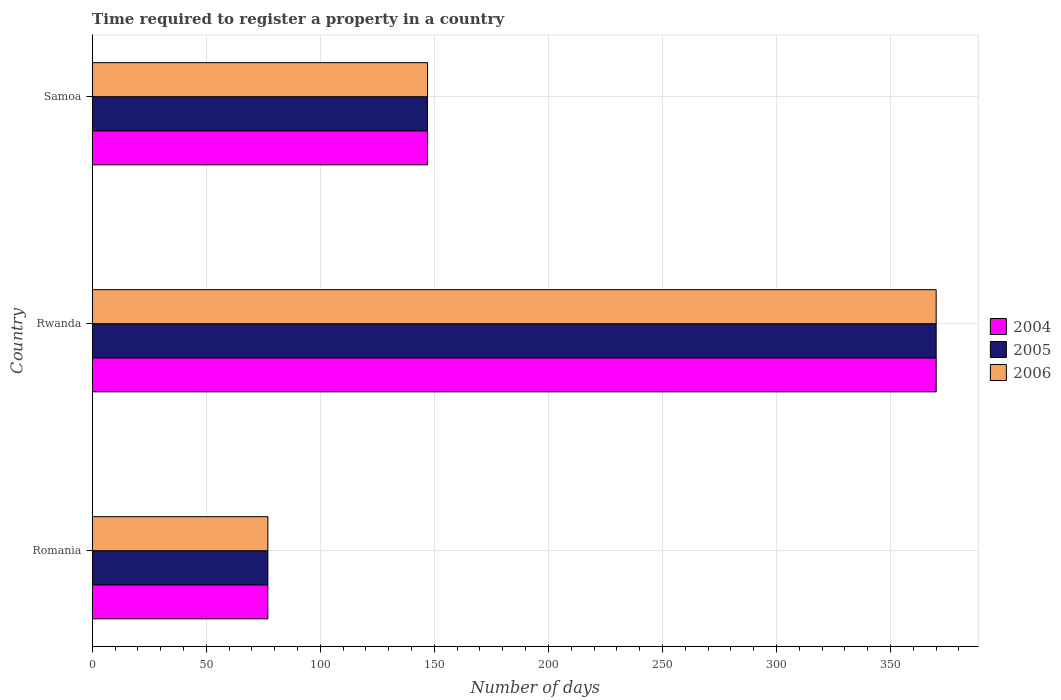Are the number of bars per tick equal to the number of legend labels?
Ensure brevity in your answer.  Yes. Are the number of bars on each tick of the Y-axis equal?
Offer a very short reply. Yes. How many bars are there on the 2nd tick from the top?
Provide a succinct answer. 3. What is the label of the 2nd group of bars from the top?
Ensure brevity in your answer.  Rwanda. What is the number of days required to register a property in 2006 in Rwanda?
Offer a very short reply. 370. Across all countries, what is the maximum number of days required to register a property in 2005?
Provide a succinct answer. 370. Across all countries, what is the minimum number of days required to register a property in 2006?
Provide a succinct answer. 77. In which country was the number of days required to register a property in 2004 maximum?
Offer a very short reply. Rwanda. In which country was the number of days required to register a property in 2005 minimum?
Offer a very short reply. Romania. What is the total number of days required to register a property in 2006 in the graph?
Offer a terse response. 594. What is the difference between the number of days required to register a property in 2005 in Romania and that in Rwanda?
Provide a succinct answer. -293. What is the difference between the number of days required to register a property in 2006 in Rwanda and the number of days required to register a property in 2004 in Samoa?
Provide a succinct answer. 223. What is the average number of days required to register a property in 2004 per country?
Your response must be concise. 198. What is the difference between the number of days required to register a property in 2005 and number of days required to register a property in 2006 in Rwanda?
Offer a very short reply. 0. What is the ratio of the number of days required to register a property in 2005 in Romania to that in Rwanda?
Provide a succinct answer. 0.21. Is the number of days required to register a property in 2004 in Romania less than that in Rwanda?
Provide a succinct answer. Yes. What is the difference between the highest and the second highest number of days required to register a property in 2004?
Your response must be concise. 223. What is the difference between the highest and the lowest number of days required to register a property in 2004?
Provide a short and direct response. 293. What does the 1st bar from the top in Samoa represents?
Your answer should be very brief. 2006. What does the 1st bar from the bottom in Rwanda represents?
Your answer should be compact. 2004. Is it the case that in every country, the sum of the number of days required to register a property in 2004 and number of days required to register a property in 2006 is greater than the number of days required to register a property in 2005?
Keep it short and to the point. Yes. How many bars are there?
Keep it short and to the point. 9. What is the difference between two consecutive major ticks on the X-axis?
Your response must be concise. 50. Does the graph contain any zero values?
Offer a terse response. No. Does the graph contain grids?
Keep it short and to the point. Yes. Where does the legend appear in the graph?
Provide a short and direct response. Center right. How many legend labels are there?
Offer a terse response. 3. How are the legend labels stacked?
Make the answer very short. Vertical. What is the title of the graph?
Keep it short and to the point. Time required to register a property in a country. What is the label or title of the X-axis?
Keep it short and to the point. Number of days. What is the Number of days in 2004 in Rwanda?
Your answer should be compact. 370. What is the Number of days of 2005 in Rwanda?
Offer a very short reply. 370. What is the Number of days of 2006 in Rwanda?
Your answer should be very brief. 370. What is the Number of days of 2004 in Samoa?
Your answer should be very brief. 147. What is the Number of days of 2005 in Samoa?
Provide a short and direct response. 147. What is the Number of days of 2006 in Samoa?
Make the answer very short. 147. Across all countries, what is the maximum Number of days in 2004?
Provide a succinct answer. 370. Across all countries, what is the maximum Number of days in 2005?
Your response must be concise. 370. Across all countries, what is the maximum Number of days of 2006?
Provide a short and direct response. 370. Across all countries, what is the minimum Number of days in 2004?
Provide a short and direct response. 77. Across all countries, what is the minimum Number of days of 2005?
Offer a very short reply. 77. Across all countries, what is the minimum Number of days of 2006?
Keep it short and to the point. 77. What is the total Number of days in 2004 in the graph?
Provide a short and direct response. 594. What is the total Number of days in 2005 in the graph?
Offer a terse response. 594. What is the total Number of days in 2006 in the graph?
Your response must be concise. 594. What is the difference between the Number of days in 2004 in Romania and that in Rwanda?
Make the answer very short. -293. What is the difference between the Number of days of 2005 in Romania and that in Rwanda?
Offer a very short reply. -293. What is the difference between the Number of days of 2006 in Romania and that in Rwanda?
Your answer should be very brief. -293. What is the difference between the Number of days of 2004 in Romania and that in Samoa?
Provide a succinct answer. -70. What is the difference between the Number of days of 2005 in Romania and that in Samoa?
Provide a short and direct response. -70. What is the difference between the Number of days of 2006 in Romania and that in Samoa?
Your response must be concise. -70. What is the difference between the Number of days in 2004 in Rwanda and that in Samoa?
Offer a very short reply. 223. What is the difference between the Number of days in 2005 in Rwanda and that in Samoa?
Ensure brevity in your answer.  223. What is the difference between the Number of days in 2006 in Rwanda and that in Samoa?
Provide a short and direct response. 223. What is the difference between the Number of days in 2004 in Romania and the Number of days in 2005 in Rwanda?
Provide a succinct answer. -293. What is the difference between the Number of days of 2004 in Romania and the Number of days of 2006 in Rwanda?
Provide a short and direct response. -293. What is the difference between the Number of days of 2005 in Romania and the Number of days of 2006 in Rwanda?
Keep it short and to the point. -293. What is the difference between the Number of days of 2004 in Romania and the Number of days of 2005 in Samoa?
Keep it short and to the point. -70. What is the difference between the Number of days in 2004 in Romania and the Number of days in 2006 in Samoa?
Offer a very short reply. -70. What is the difference between the Number of days in 2005 in Romania and the Number of days in 2006 in Samoa?
Keep it short and to the point. -70. What is the difference between the Number of days of 2004 in Rwanda and the Number of days of 2005 in Samoa?
Provide a succinct answer. 223. What is the difference between the Number of days of 2004 in Rwanda and the Number of days of 2006 in Samoa?
Ensure brevity in your answer.  223. What is the difference between the Number of days in 2005 in Rwanda and the Number of days in 2006 in Samoa?
Offer a very short reply. 223. What is the average Number of days in 2004 per country?
Your response must be concise. 198. What is the average Number of days of 2005 per country?
Make the answer very short. 198. What is the average Number of days in 2006 per country?
Make the answer very short. 198. What is the difference between the Number of days in 2005 and Number of days in 2006 in Romania?
Provide a short and direct response. 0. What is the difference between the Number of days of 2004 and Number of days of 2005 in Rwanda?
Your response must be concise. 0. What is the difference between the Number of days in 2005 and Number of days in 2006 in Rwanda?
Your answer should be very brief. 0. What is the difference between the Number of days of 2005 and Number of days of 2006 in Samoa?
Ensure brevity in your answer.  0. What is the ratio of the Number of days in 2004 in Romania to that in Rwanda?
Provide a succinct answer. 0.21. What is the ratio of the Number of days of 2005 in Romania to that in Rwanda?
Your answer should be compact. 0.21. What is the ratio of the Number of days in 2006 in Romania to that in Rwanda?
Ensure brevity in your answer.  0.21. What is the ratio of the Number of days in 2004 in Romania to that in Samoa?
Offer a very short reply. 0.52. What is the ratio of the Number of days in 2005 in Romania to that in Samoa?
Offer a very short reply. 0.52. What is the ratio of the Number of days of 2006 in Romania to that in Samoa?
Provide a short and direct response. 0.52. What is the ratio of the Number of days of 2004 in Rwanda to that in Samoa?
Offer a very short reply. 2.52. What is the ratio of the Number of days of 2005 in Rwanda to that in Samoa?
Your answer should be compact. 2.52. What is the ratio of the Number of days of 2006 in Rwanda to that in Samoa?
Your response must be concise. 2.52. What is the difference between the highest and the second highest Number of days of 2004?
Make the answer very short. 223. What is the difference between the highest and the second highest Number of days in 2005?
Keep it short and to the point. 223. What is the difference between the highest and the second highest Number of days of 2006?
Ensure brevity in your answer.  223. What is the difference between the highest and the lowest Number of days of 2004?
Provide a succinct answer. 293. What is the difference between the highest and the lowest Number of days in 2005?
Offer a terse response. 293. What is the difference between the highest and the lowest Number of days of 2006?
Provide a short and direct response. 293. 